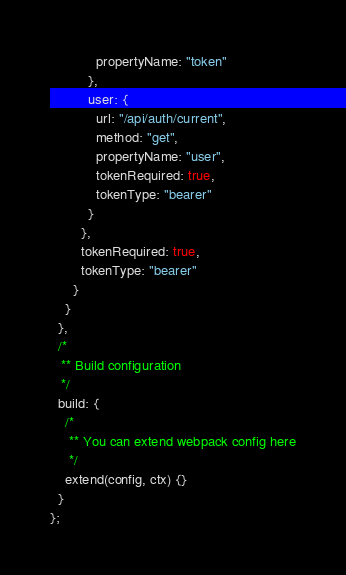Convert code to text. <code><loc_0><loc_0><loc_500><loc_500><_JavaScript_>            propertyName: "token"
          },
          user: {
            url: "/api/auth/current",
            method: "get",
            propertyName: "user",
            tokenRequired: true,
            tokenType: "bearer"
          }
        },
        tokenRequired: true,
        tokenType: "bearer"
      }
    }
  },
  /*
   ** Build configuration
   */
  build: {
    /*
     ** You can extend webpack config here
     */
    extend(config, ctx) {}
  }
};
</code> 